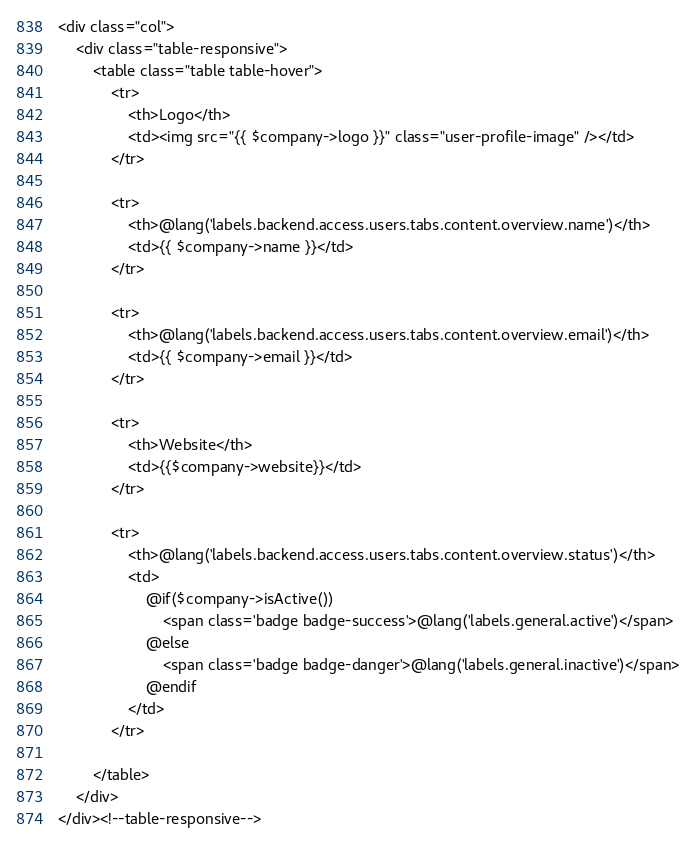<code> <loc_0><loc_0><loc_500><loc_500><_PHP_><div class="col">
    <div class="table-responsive">
        <table class="table table-hover">
            <tr>
                <th>Logo</th>
                <td><img src="{{ $company->logo }}" class="user-profile-image" /></td>
            </tr>

            <tr>
                <th>@lang('labels.backend.access.users.tabs.content.overview.name')</th>
                <td>{{ $company->name }}</td>
            </tr>

            <tr>
                <th>@lang('labels.backend.access.users.tabs.content.overview.email')</th>
                <td>{{ $company->email }}</td>
            </tr>

            <tr>
                <th>Website</th>
                <td>{{$company->website}}</td>
            </tr>

            <tr>
                <th>@lang('labels.backend.access.users.tabs.content.overview.status')</th>
                <td>
                    @if($company->isActive())
                        <span class='badge badge-success'>@lang('labels.general.active')</span>
                    @else
                        <span class='badge badge-danger'>@lang('labels.general.inactive')</span>
                    @endif
                </td>
            </tr>

        </table>
    </div>
</div><!--table-responsive-->
</code> 